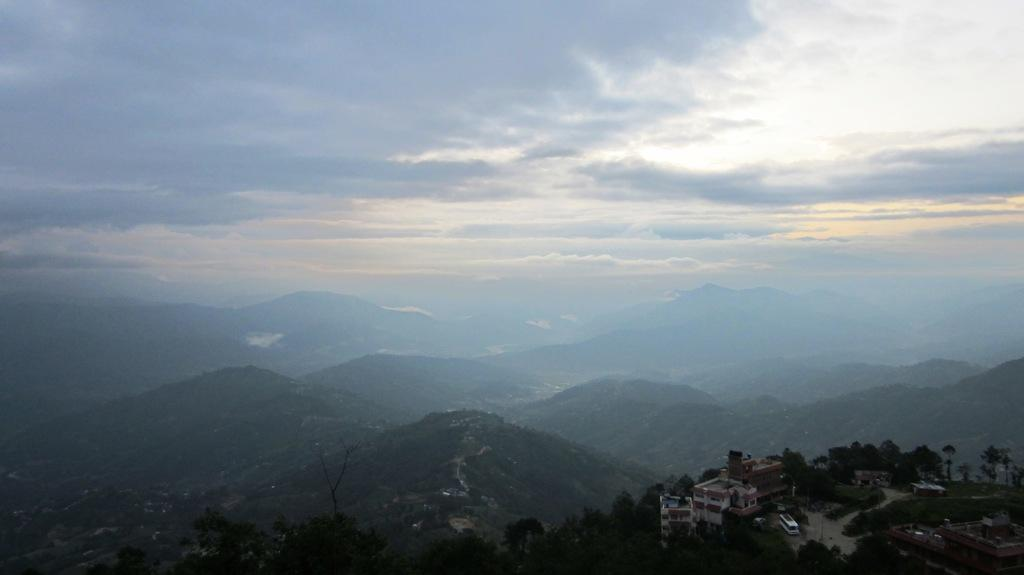What type of natural formation can be seen in the image? There are mountains in the image. What is visible in the sky at the top of the image? The sky is covered with clouds at the top of the image. What type of vegetation is visible at the bottom of the image? Trees are visible at the bottom of the image. What type of man-made structures are present at the bottom of the image? Buildings are present at the bottom of the image. What type of vehicles can be seen at the bottom of the image? Buses are in the image at the bottom. Where is the grape located in the image? There is no grape present in the image. What type of place is depicted in the image? The image does not depict a specific place; it shows mountains, clouds, trees, buildings, and buses. 